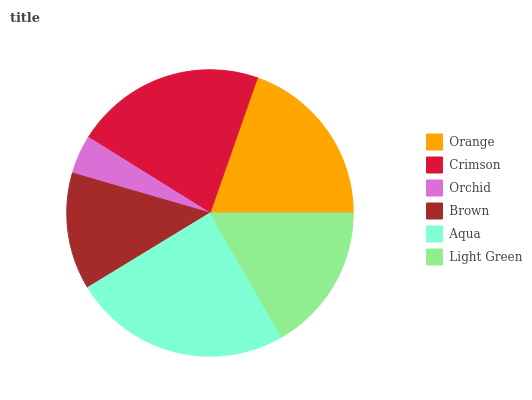Is Orchid the minimum?
Answer yes or no. Yes. Is Aqua the maximum?
Answer yes or no. Yes. Is Crimson the minimum?
Answer yes or no. No. Is Crimson the maximum?
Answer yes or no. No. Is Crimson greater than Orange?
Answer yes or no. Yes. Is Orange less than Crimson?
Answer yes or no. Yes. Is Orange greater than Crimson?
Answer yes or no. No. Is Crimson less than Orange?
Answer yes or no. No. Is Orange the high median?
Answer yes or no. Yes. Is Light Green the low median?
Answer yes or no. Yes. Is Crimson the high median?
Answer yes or no. No. Is Orange the low median?
Answer yes or no. No. 